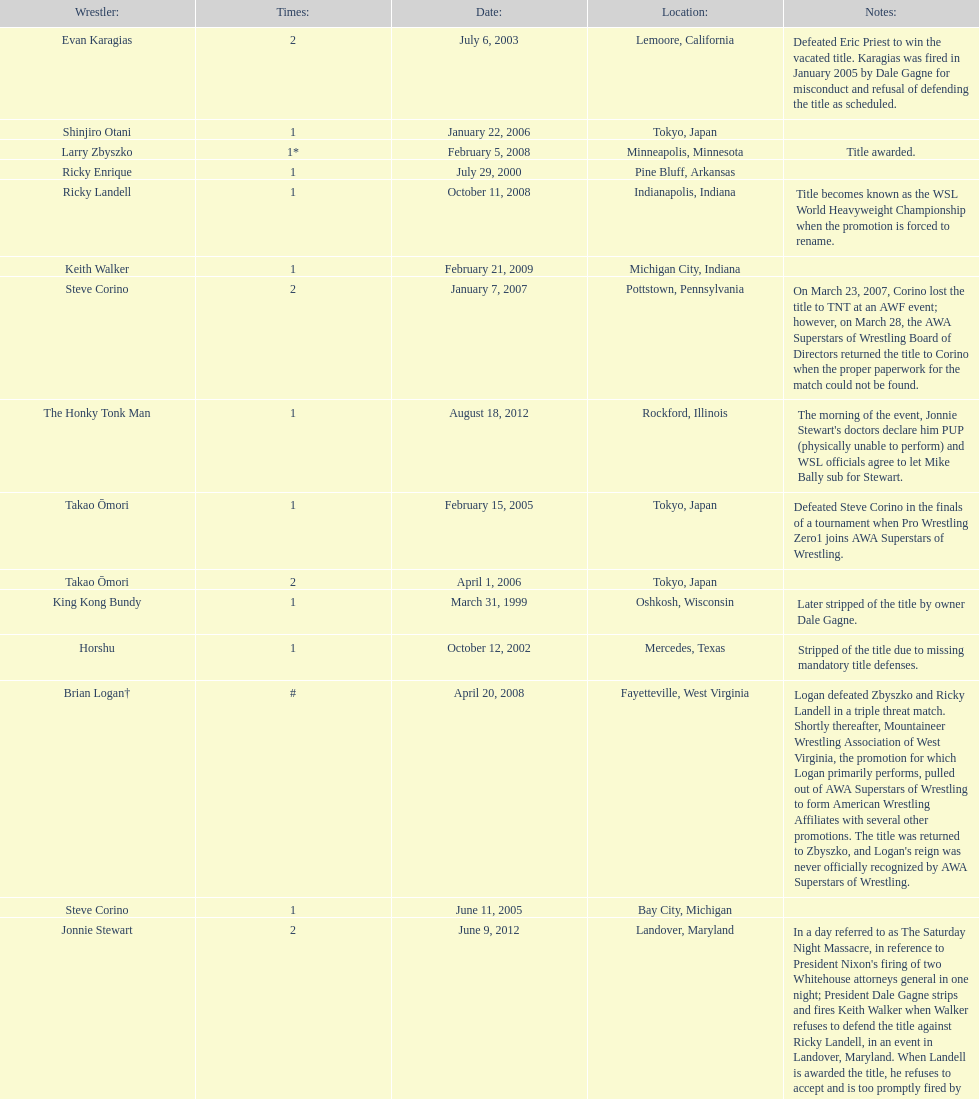When did steve corino win his first wsl title? June 11, 2005. 